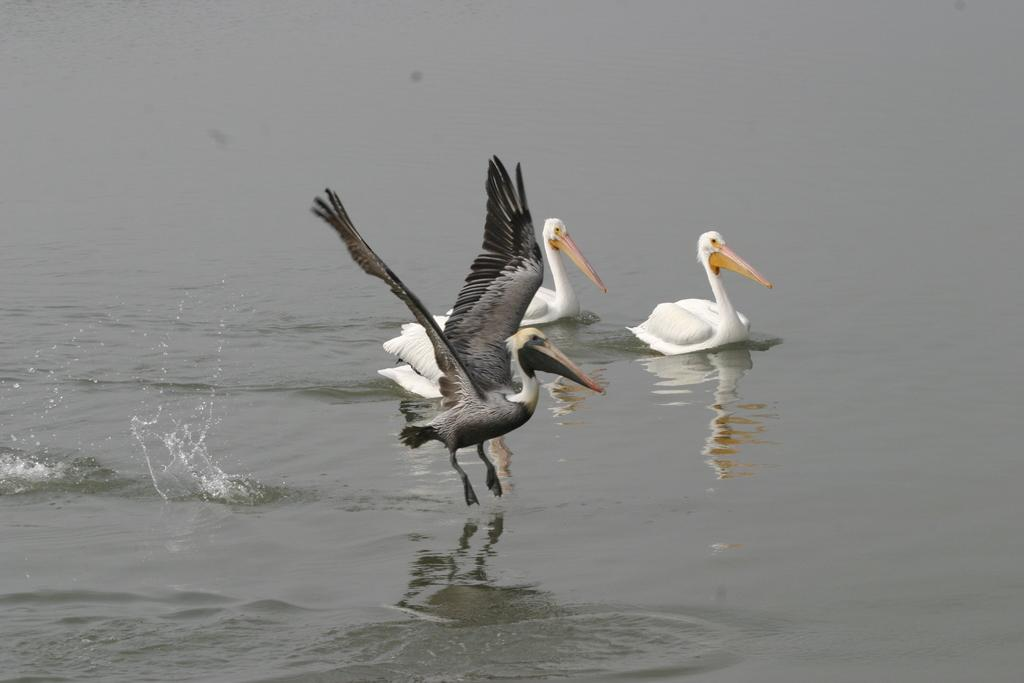What type of animals can be seen in the water in the image? There are birds in the water in the image. Can you describe the position of one of the birds in the image? Yes, there is a bird in a flying position in the image. What type of rice is being harvested by the cattle in the image? There are no cattle or rice present in the image; it features birds in the water and a bird in a flying position. 